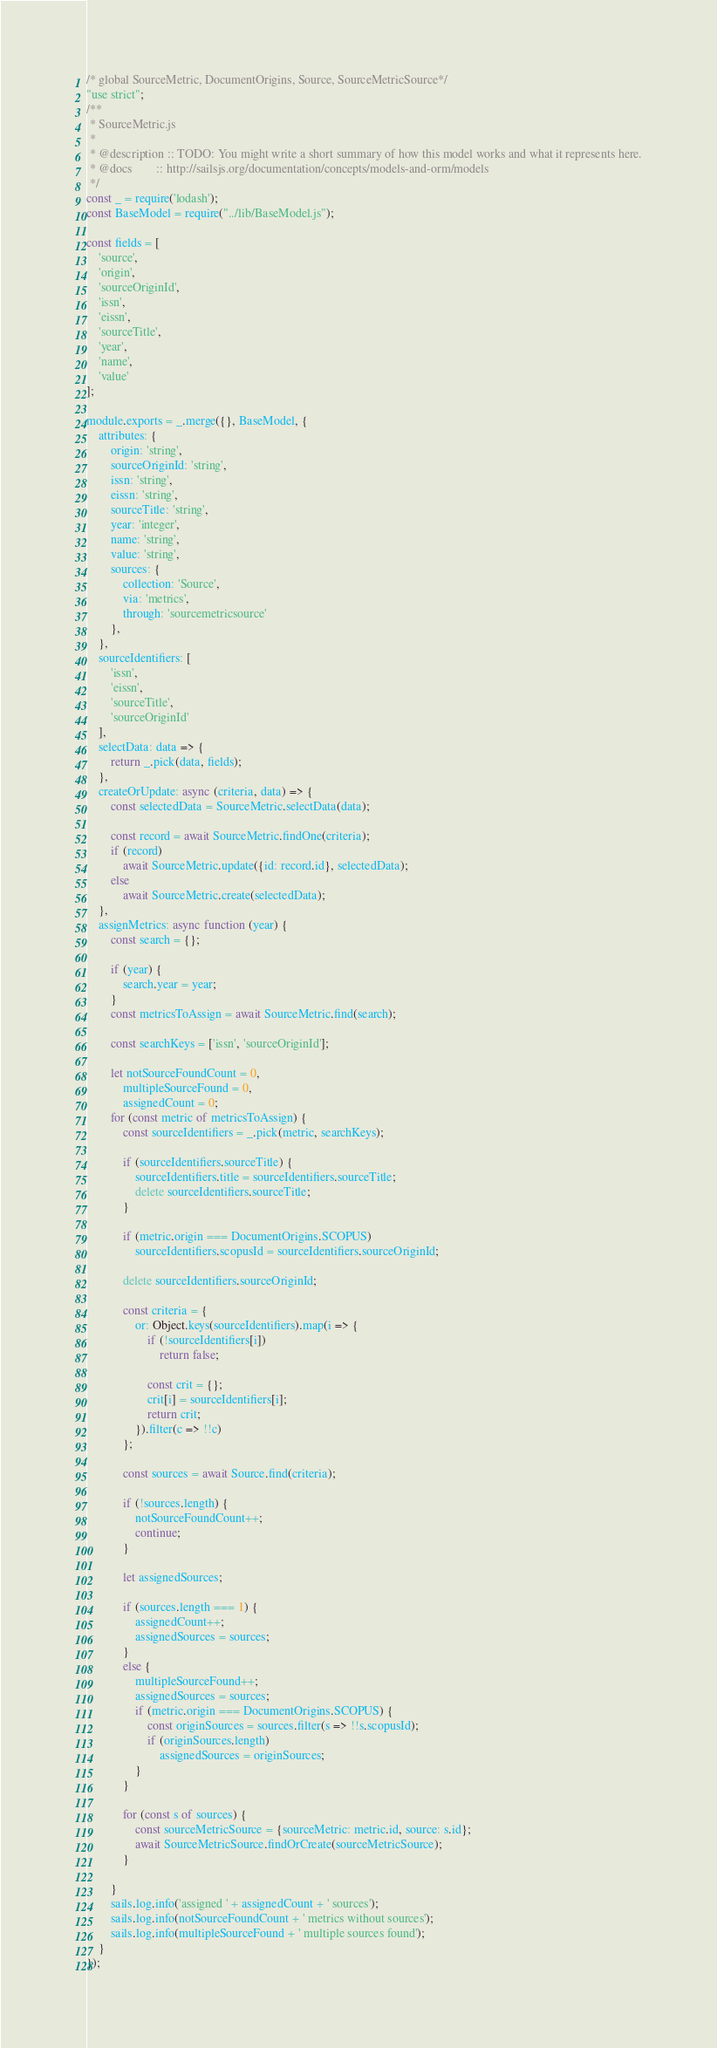<code> <loc_0><loc_0><loc_500><loc_500><_JavaScript_>/* global SourceMetric, DocumentOrigins, Source, SourceMetricSource*/
"use strict";
/**
 * SourceMetric.js
 *
 * @description :: TODO: You might write a short summary of how this model works and what it represents here.
 * @docs        :: http://sailsjs.org/documentation/concepts/models-and-orm/models
 */
const _ = require('lodash');
const BaseModel = require("../lib/BaseModel.js");

const fields = [
    'source',
    'origin',
    'sourceOriginId',
    'issn',
    'eissn',
    'sourceTitle',
    'year',
    'name',
    'value'
];

module.exports = _.merge({}, BaseModel, {
    attributes: {
        origin: 'string',
        sourceOriginId: 'string',
        issn: 'string',
        eissn: 'string',
        sourceTitle: 'string',
        year: 'integer',
        name: 'string',
        value: 'string',
        sources: {
            collection: 'Source',
            via: 'metrics',
            through: 'sourcemetricsource'
        },
    },
    sourceIdentifiers: [
        'issn',
        'eissn',
        'sourceTitle',
        'sourceOriginId'
    ],
    selectData: data => {
        return _.pick(data, fields);
    },
    createOrUpdate: async (criteria, data) => {
        const selectedData = SourceMetric.selectData(data);

        const record = await SourceMetric.findOne(criteria);
        if (record)
            await SourceMetric.update({id: record.id}, selectedData);
        else
            await SourceMetric.create(selectedData);
    },
    assignMetrics: async function (year) {
        const search = {};

        if (year) {
            search.year = year;
        }
        const metricsToAssign = await SourceMetric.find(search);

        const searchKeys = ['issn', 'sourceOriginId'];

        let notSourceFoundCount = 0,
            multipleSourceFound = 0,
            assignedCount = 0;
        for (const metric of metricsToAssign) {
            const sourceIdentifiers = _.pick(metric, searchKeys);

            if (sourceIdentifiers.sourceTitle) {
                sourceIdentifiers.title = sourceIdentifiers.sourceTitle;
                delete sourceIdentifiers.sourceTitle;
            }

            if (metric.origin === DocumentOrigins.SCOPUS)
                sourceIdentifiers.scopusId = sourceIdentifiers.sourceOriginId;

            delete sourceIdentifiers.sourceOriginId;

            const criteria = {
                or: Object.keys(sourceIdentifiers).map(i => {
                    if (!sourceIdentifiers[i])
                        return false;

                    const crit = {};
                    crit[i] = sourceIdentifiers[i];
                    return crit;
                }).filter(c => !!c)
            };

            const sources = await Source.find(criteria);

            if (!sources.length) {
                notSourceFoundCount++;
                continue;
            }

            let assignedSources;

            if (sources.length === 1) {
                assignedCount++;
                assignedSources = sources;
            }
            else {
                multipleSourceFound++;
                assignedSources = sources;
                if (metric.origin === DocumentOrigins.SCOPUS) {
                    const originSources = sources.filter(s => !!s.scopusId);
                    if (originSources.length)
                        assignedSources = originSources;
                }
            }

            for (const s of sources) {
                const sourceMetricSource = {sourceMetric: metric.id, source: s.id};
                await SourceMetricSource.findOrCreate(sourceMetricSource);
            }

        }
        sails.log.info('assigned ' + assignedCount + ' sources');
        sails.log.info(notSourceFoundCount + ' metrics without sources');
        sails.log.info(multipleSourceFound + ' multiple sources found');
    }
});</code> 